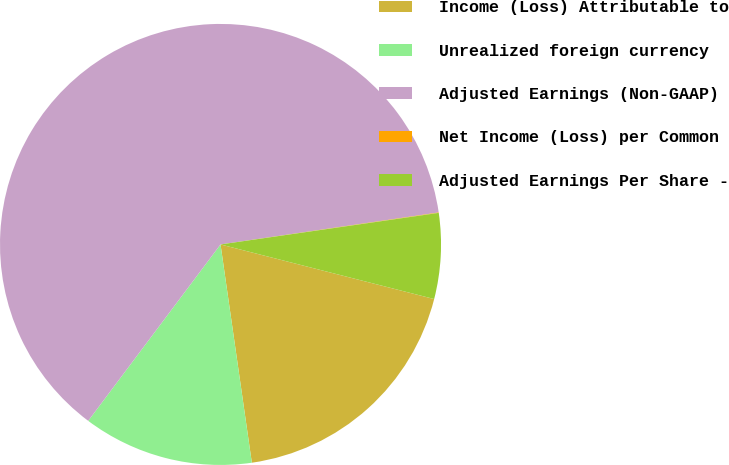Convert chart to OTSL. <chart><loc_0><loc_0><loc_500><loc_500><pie_chart><fcel>Income (Loss) Attributable to<fcel>Unrealized foreign currency<fcel>Adjusted Earnings (Non-GAAP)<fcel>Net Income (Loss) per Common<fcel>Adjusted Earnings Per Share -<nl><fcel>18.75%<fcel>12.51%<fcel>62.44%<fcel>0.03%<fcel>6.27%<nl></chart> 